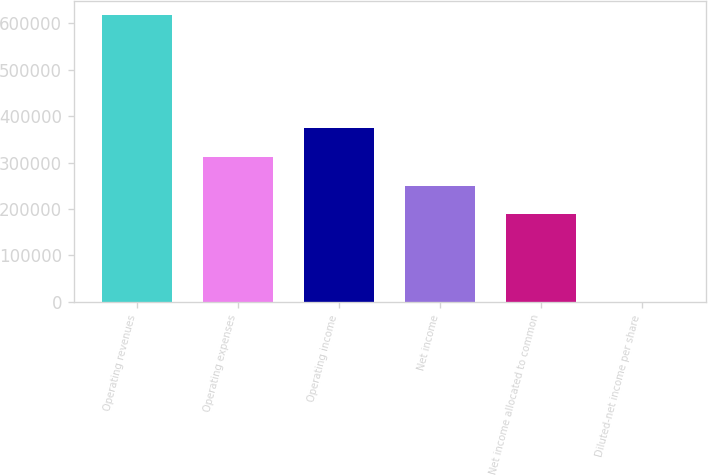Convert chart. <chart><loc_0><loc_0><loc_500><loc_500><bar_chart><fcel>Operating revenues<fcel>Operating expenses<fcel>Operating income<fcel>Net income<fcel>Net income allocated to common<fcel>Diluted-net income per share<nl><fcel>617225<fcel>311837<fcel>373559<fcel>250114<fcel>188392<fcel>2.21<nl></chart> 